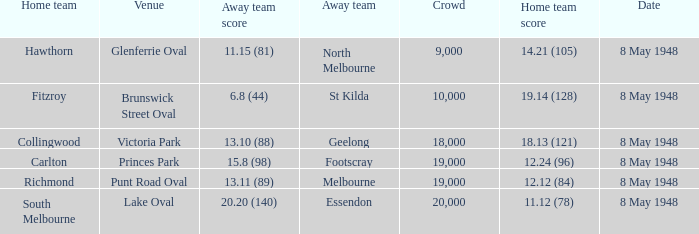Which away team has a home score of 14.21 (105)? North Melbourne. 